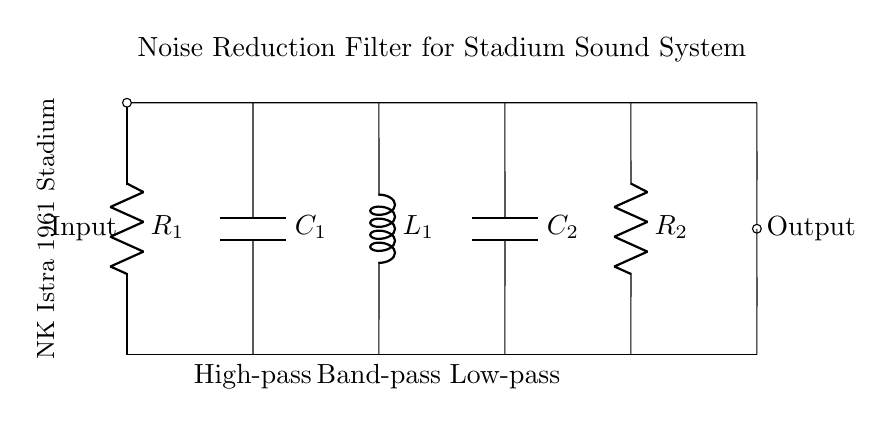What is the type of the first component in the circuit? The first component from the top is a resistor, labeled R1. This is confirmed by its position in the circuit diagram and the component labeling.
Answer: Resistor What is the output point of the filter? The output point is indicated at the end of the circuit where it states "Output." This shows where the filtered signal can be taken from after passing through the filter components.
Answer: Output How many components are used in series? In total, there are four components connected in series: R1, C1, L1, and C2. However, R2 is also connected in series when considering the overall signal path. Each component effectively connects one after another without any branching.
Answer: Four What is the function of component L1? Component L1, which is an inductor, is designed to provide a band-pass function in the filter circuit. This means it will allow a specific frequency range to pass while attenuating frequencies outside of that range.
Answer: Band-pass What type of filter is designed in this circuit? The circuit diagram illustrates a noise reduction filter, which incorporates high-pass, low-pass, and band-pass elements. This combination effectively filters out unwanted noise while allowing desired signals to remain intact.
Answer: Noise reduction filter What is the labeling indicating for C1 in the context of filtering? C1 is labeled below as a "High-pass" capacitor. This indicates that its purpose is to allow high frequencies to pass while blocking lower frequencies in the audio signal.
Answer: High-pass What overall configuration can you identify from the components? The components are arranged to form a cascaded filter configuration, utilizing resistors, capacitors, and inductors to achieve the desired noise reduction function. This setup filters signals at different frequency ranges effectively.
Answer: Cascaded filter configuration 